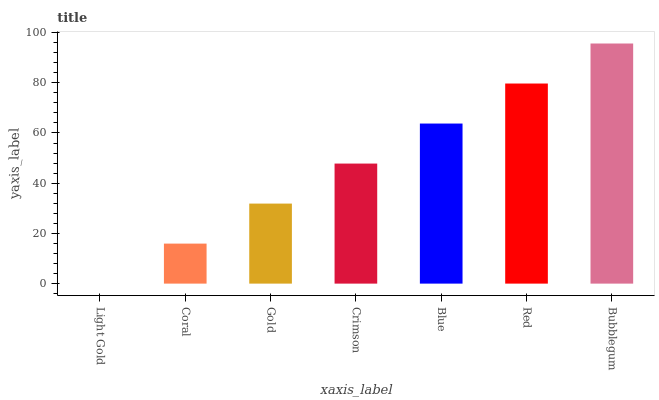Is Coral the minimum?
Answer yes or no. No. Is Coral the maximum?
Answer yes or no. No. Is Coral greater than Light Gold?
Answer yes or no. Yes. Is Light Gold less than Coral?
Answer yes or no. Yes. Is Light Gold greater than Coral?
Answer yes or no. No. Is Coral less than Light Gold?
Answer yes or no. No. Is Crimson the high median?
Answer yes or no. Yes. Is Crimson the low median?
Answer yes or no. Yes. Is Bubblegum the high median?
Answer yes or no. No. Is Coral the low median?
Answer yes or no. No. 